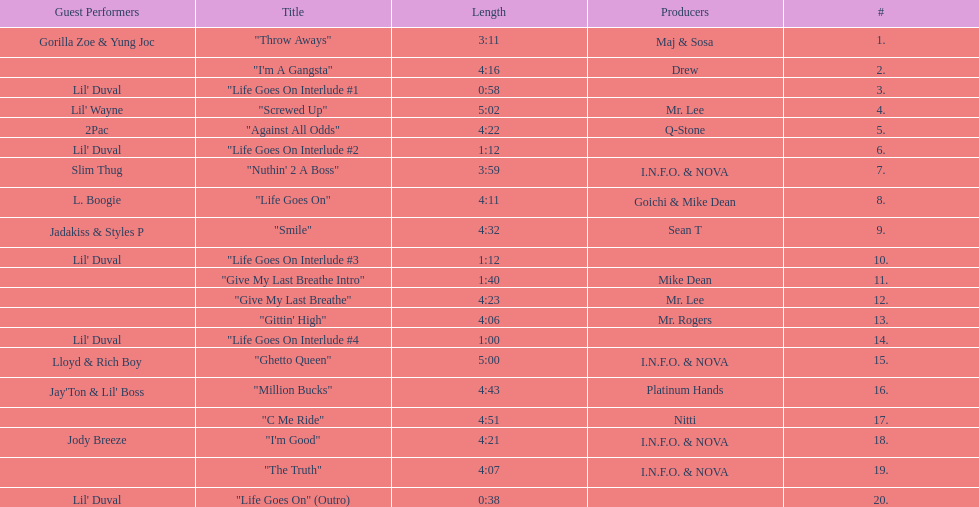What is the last track produced by mr. lee? "Give My Last Breathe". 